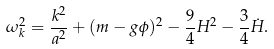Convert formula to latex. <formula><loc_0><loc_0><loc_500><loc_500>\omega _ { k } ^ { 2 } = \frac { k ^ { 2 } } { a ^ { 2 } } + ( m - g \phi ) ^ { 2 } - \frac { 9 } { 4 } H ^ { 2 } - \frac { 3 } { 4 } \dot { H } .</formula> 